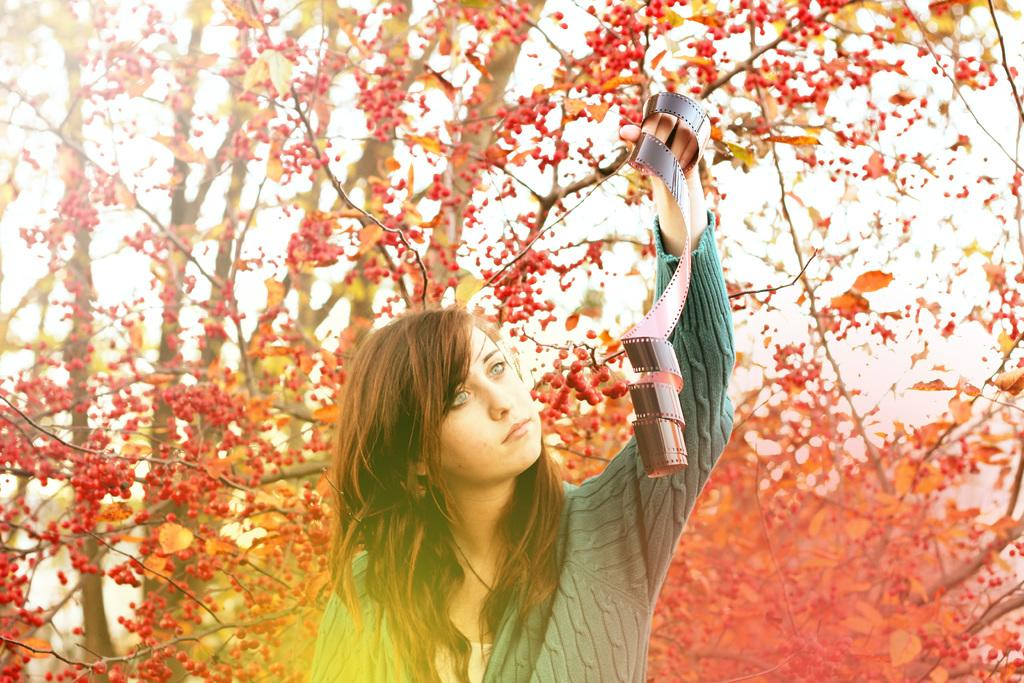Who or what is present in the image? There is a person in the image. What is the person holding in their hand? The person is holding a reel with one hand. What can be seen in the background of the image? There are trees with red color fruits in the background. What part of the natural environment is visible in the image? The sky is visible in the image. What type of pickle is being shown in the image? There is no pickle present in the image. How does the person in the image plan to resolve their trouble with the reel? The image does not provide any information about the person's troubles or intentions, so we cannot answer this question. 